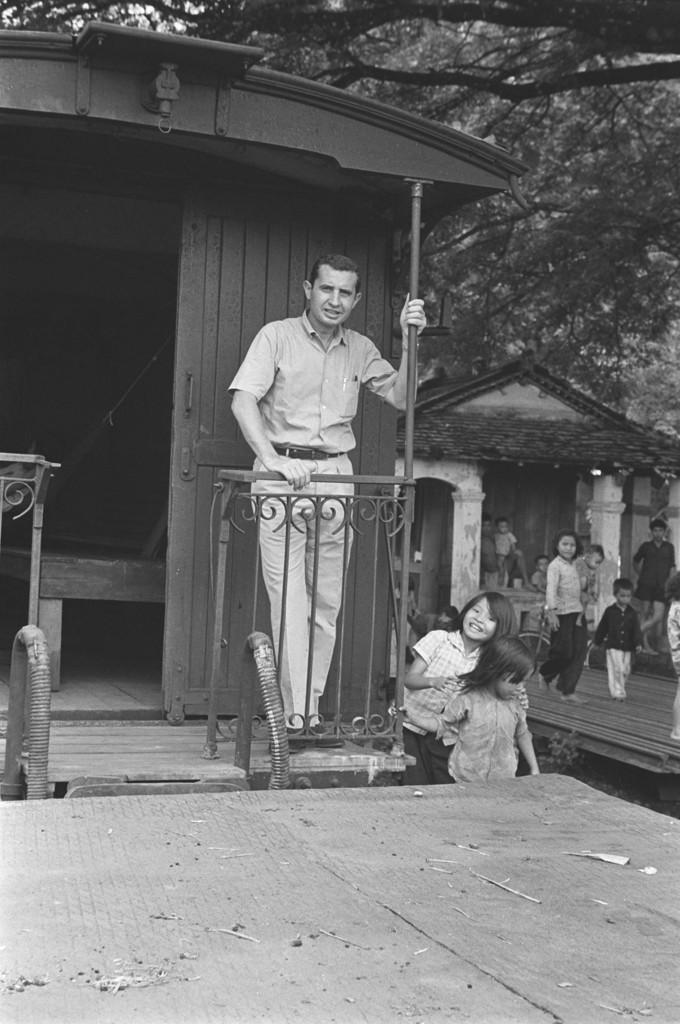Can you describe this image briefly? In this image we can see a person standing beside the house. We can also see the children behind him. On the backside we can see a house with roof and pillars and the trees. 